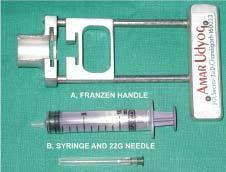s equipments required for transcutaneous fnac?
Answer the question using a single word or phrase. Yes 